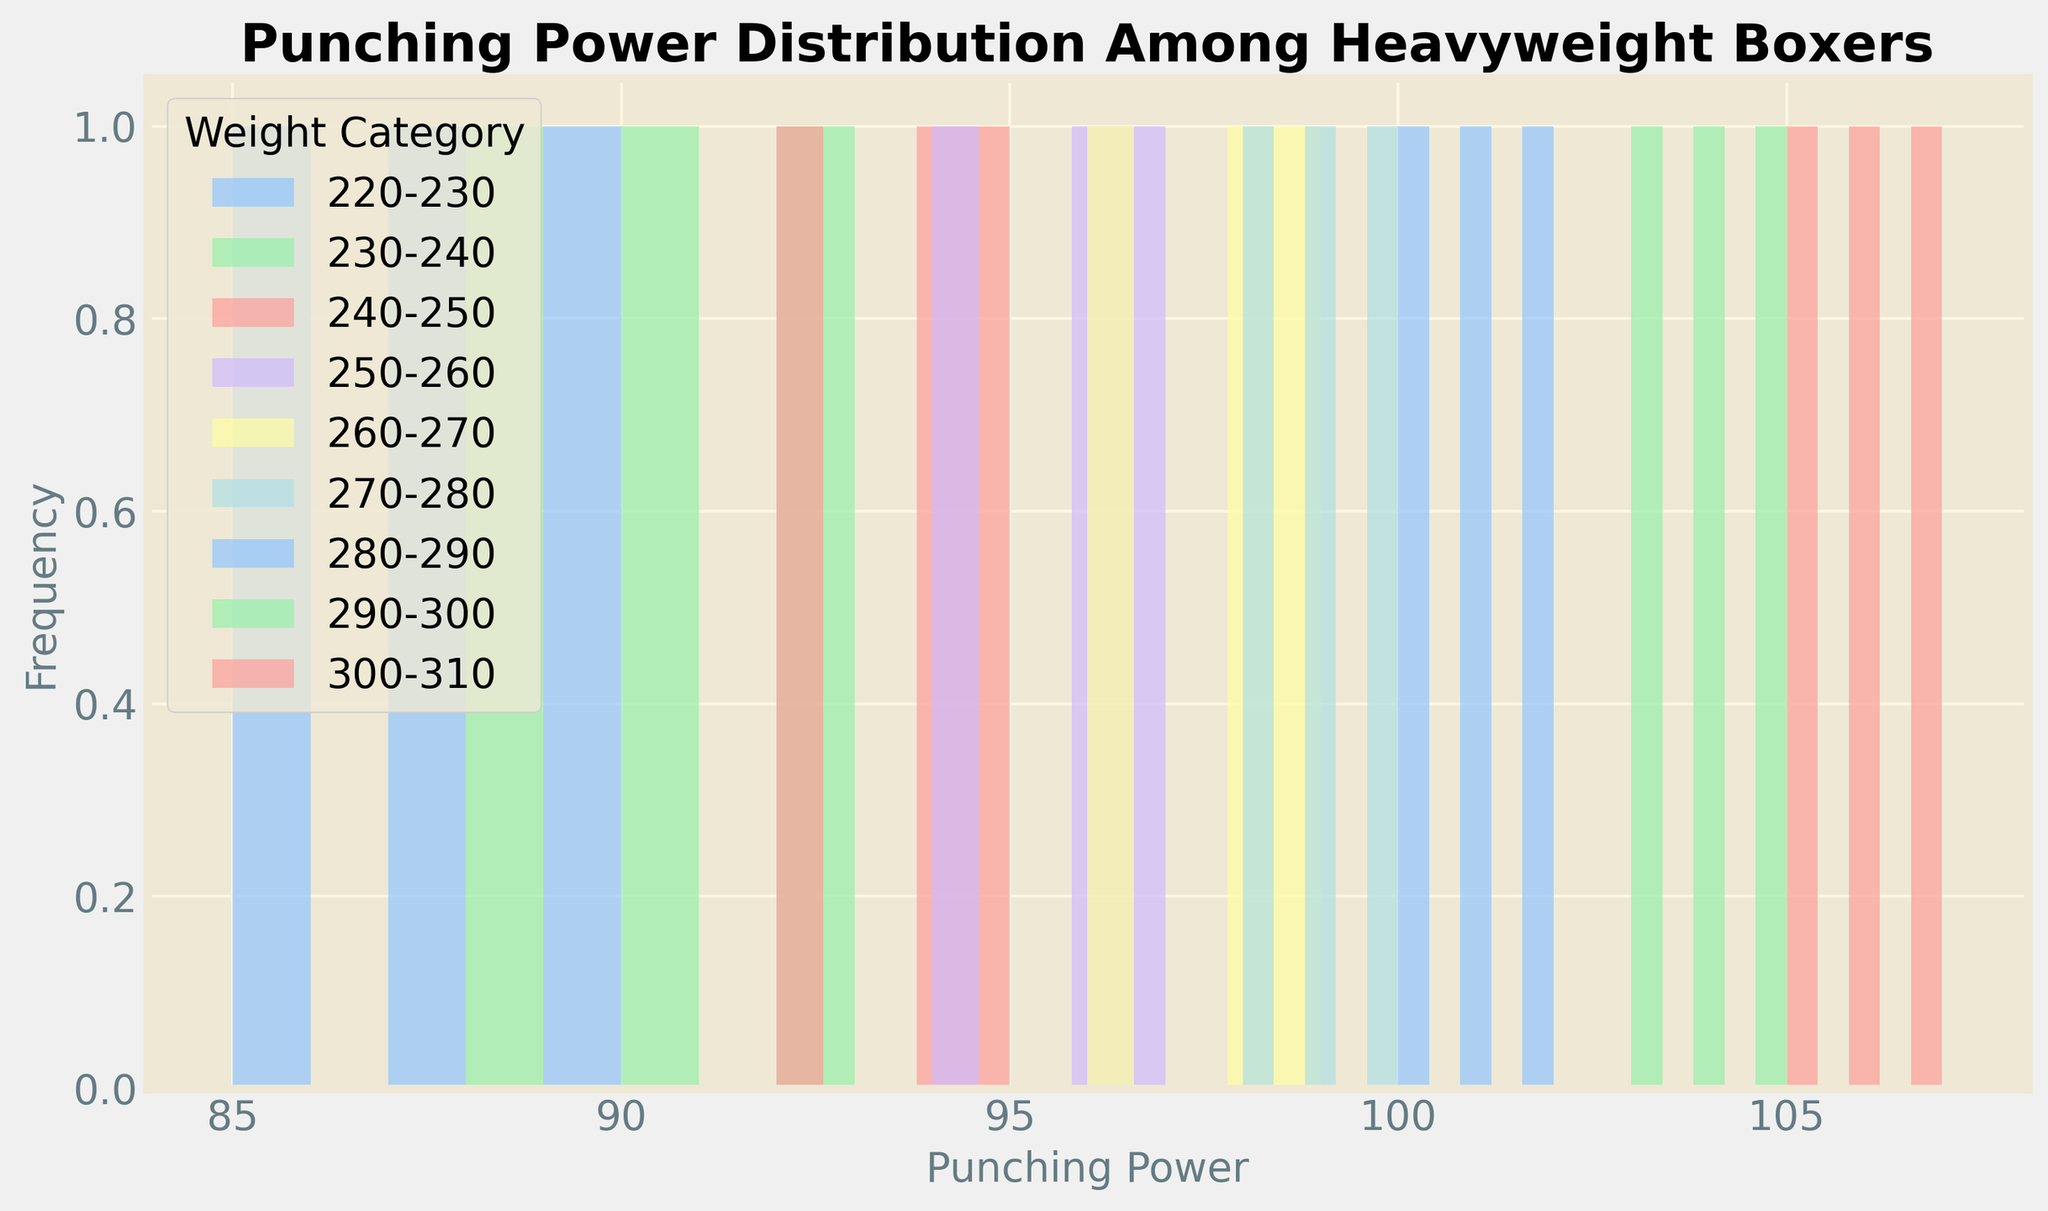Which weight category has the highest punching power? Look at the rightmost part of the histogram and find the weight category associated with the highest punching power value. The weight category 300-310 lbs has a peak at 107, which is higher than any other category.
Answer: 300-310 Which weight category has the most variation in punching power? The bins representing the widest range of punching power values indicate more variation. The category 290-300 lbs spans from 103 to 105, suggesting it has notable variation.
Answer: 290-300 What is the average punching power for the 240-250 lbs category? Identify the punching power values for the 240-250 lbs category: [95, 92, 94]. Calculate the average: (95 + 92 + 94)/3 = 93.7.
Answer: 93.7 Comparing 220-230 lbs and 260-270 lbs, which has a higher median punching power? Check the middle values of each range [90, 85, 87] for 220-230 lbs and [99, 96, 98] for 260-270 lbs. Medians are 87 for 220-230 lbs and 98 for 260-270 lbs.
Answer: 260-270 What is the range of punching power for the 250-260 lbs category? Identify the minimum and maximum punching power for the 250-260 lbs category: [97, 94, 96]. Range is from 94 to 97. Range = 97 - 94 = 3.
Answer: 3 Which weight category has the narrowest distribution of punching power? Look for the category where punching power values are the closest. The 220-230 lbs category has values [90, 85, 87], which are quite close to each other compared to other categories.
Answer: 220-230 What is the total frequency of the 270-280 lbs weight category? Count the occurrences within the 270-280 lbs category. It appears three times: [100, 98, 99].
Answer: 3 For the 280-290 lbs category, what is the punch power difference between the highest and lowest frequencies? Identify the punch power values: [102, 100, 101]. The highest is 102 and the lowest is 100. Difference = 102 - 100 = 2.
Answer: 2 Are there any categories with identical maximum or equal minimum punching power values? Compare histograms side by side. Both the 260-270 and 270-280 lbs categories have a maximum value of 99.
Answer: Yes In the 300-310 lbs category, how much greater is the maximum punching power compared to the minimum? Compare the values [107, 105, 106], where maximum is 107 and minimum is 105. Difference = 107 - 105 = 2.
Answer: 2 